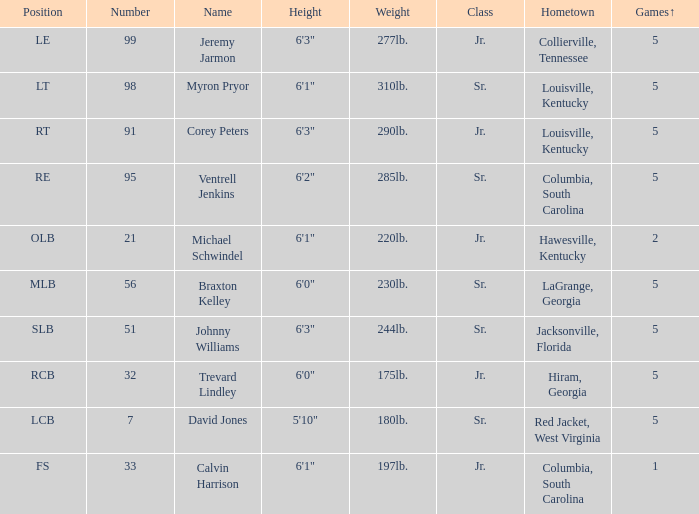How many players were 6'1" and from Columbia, South Carolina? 1.0. 